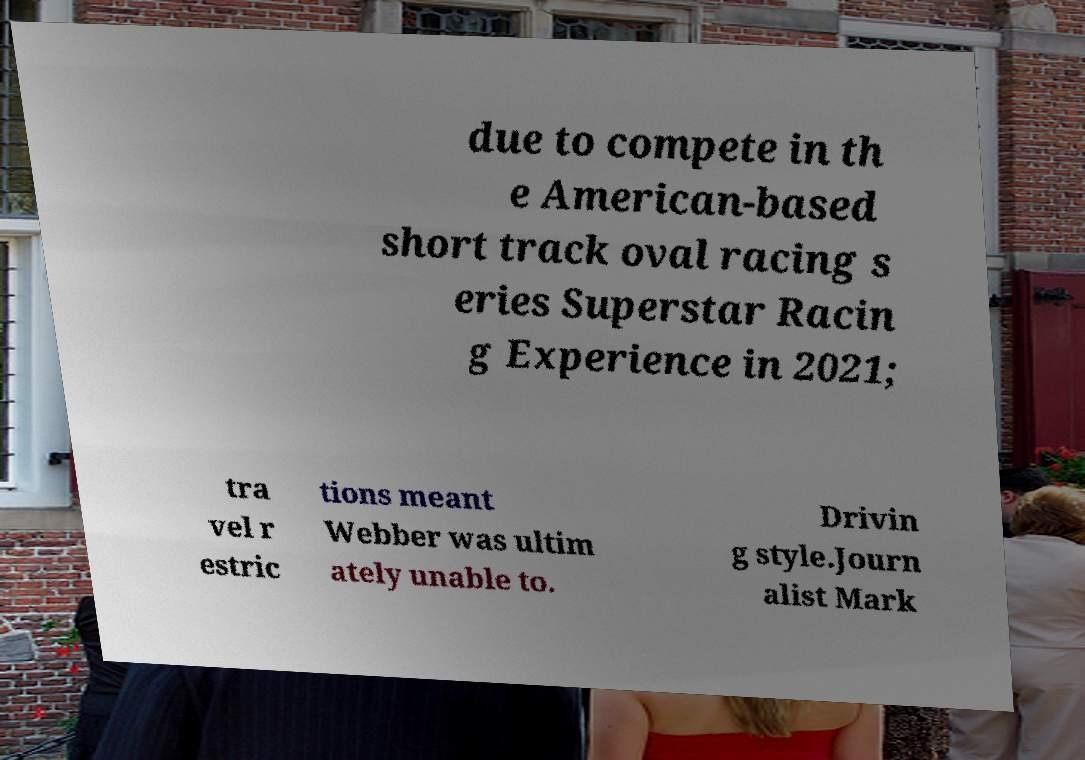I need the written content from this picture converted into text. Can you do that? due to compete in th e American-based short track oval racing s eries Superstar Racin g Experience in 2021; tra vel r estric tions meant Webber was ultim ately unable to. Drivin g style.Journ alist Mark 